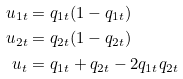<formula> <loc_0><loc_0><loc_500><loc_500>u _ { 1 t } & = q _ { 1 t } ( 1 - q _ { 1 t } ) \\ u _ { 2 t } & = q _ { 2 t } ( 1 - q _ { 2 t } ) \\ u _ { t } & = q _ { 1 t } + q _ { 2 t } - 2 q _ { 1 t } q _ { 2 t }</formula> 